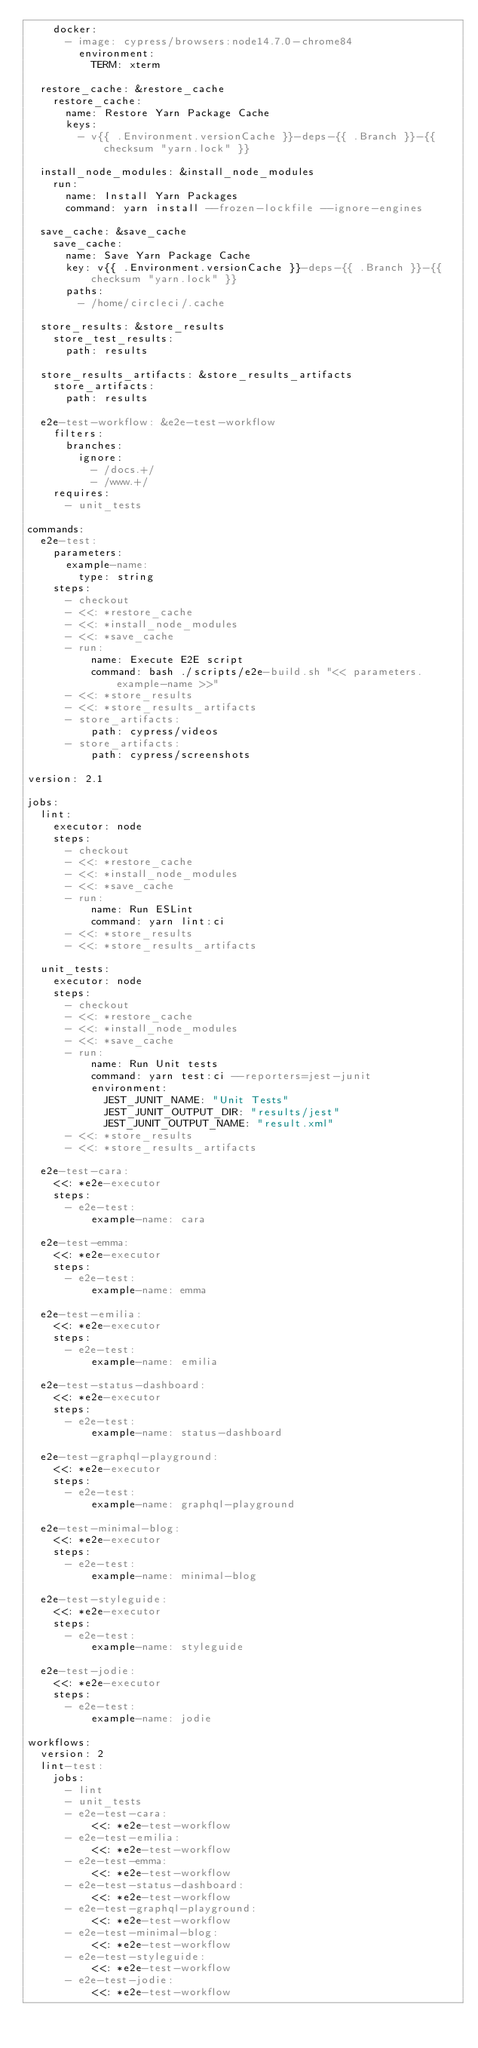<code> <loc_0><loc_0><loc_500><loc_500><_YAML_>    docker:
      - image: cypress/browsers:node14.7.0-chrome84
        environment:
          TERM: xterm

  restore_cache: &restore_cache
    restore_cache:
      name: Restore Yarn Package Cache
      keys:
        - v{{ .Environment.versionCache }}-deps-{{ .Branch }}-{{ checksum "yarn.lock" }}

  install_node_modules: &install_node_modules
    run:
      name: Install Yarn Packages
      command: yarn install --frozen-lockfile --ignore-engines

  save_cache: &save_cache
    save_cache:
      name: Save Yarn Package Cache
      key: v{{ .Environment.versionCache }}-deps-{{ .Branch }}-{{ checksum "yarn.lock" }}
      paths:
        - /home/circleci/.cache

  store_results: &store_results
    store_test_results:
      path: results

  store_results_artifacts: &store_results_artifacts
    store_artifacts:
      path: results

  e2e-test-workflow: &e2e-test-workflow
    filters:
      branches:
        ignore:
          - /docs.+/
          - /www.+/
    requires:
      - unit_tests

commands:
  e2e-test:
    parameters:
      example-name:
        type: string
    steps:
      - checkout
      - <<: *restore_cache
      - <<: *install_node_modules
      - <<: *save_cache
      - run:
          name: Execute E2E script
          command: bash ./scripts/e2e-build.sh "<< parameters.example-name >>"
      - <<: *store_results
      - <<: *store_results_artifacts
      - store_artifacts:
          path: cypress/videos
      - store_artifacts:
          path: cypress/screenshots

version: 2.1

jobs:
  lint:
    executor: node
    steps:
      - checkout
      - <<: *restore_cache
      - <<: *install_node_modules
      - <<: *save_cache
      - run:
          name: Run ESLint
          command: yarn lint:ci
      - <<: *store_results
      - <<: *store_results_artifacts

  unit_tests:
    executor: node
    steps:
      - checkout
      - <<: *restore_cache
      - <<: *install_node_modules
      - <<: *save_cache
      - run:
          name: Run Unit tests
          command: yarn test:ci --reporters=jest-junit
          environment:
            JEST_JUNIT_NAME: "Unit Tests"
            JEST_JUNIT_OUTPUT_DIR: "results/jest"
            JEST_JUNIT_OUTPUT_NAME: "result.xml"
      - <<: *store_results
      - <<: *store_results_artifacts

  e2e-test-cara:
    <<: *e2e-executor
    steps:
      - e2e-test:
          example-name: cara

  e2e-test-emma:
    <<: *e2e-executor
    steps:
      - e2e-test:
          example-name: emma

  e2e-test-emilia:
    <<: *e2e-executor
    steps:
      - e2e-test:
          example-name: emilia

  e2e-test-status-dashboard:
    <<: *e2e-executor
    steps:
      - e2e-test:
          example-name: status-dashboard

  e2e-test-graphql-playground:
    <<: *e2e-executor
    steps:
      - e2e-test:
          example-name: graphql-playground

  e2e-test-minimal-blog:
    <<: *e2e-executor
    steps:
      - e2e-test:
          example-name: minimal-blog

  e2e-test-styleguide:
    <<: *e2e-executor
    steps:
      - e2e-test:
          example-name: styleguide

  e2e-test-jodie:
    <<: *e2e-executor
    steps:
      - e2e-test:
          example-name: jodie

workflows:
  version: 2
  lint-test:
    jobs:
      - lint
      - unit_tests
      - e2e-test-cara:
          <<: *e2e-test-workflow
      - e2e-test-emilia:
          <<: *e2e-test-workflow
      - e2e-test-emma:
          <<: *e2e-test-workflow
      - e2e-test-status-dashboard:
          <<: *e2e-test-workflow
      - e2e-test-graphql-playground:
          <<: *e2e-test-workflow
      - e2e-test-minimal-blog:
          <<: *e2e-test-workflow
      - e2e-test-styleguide:
          <<: *e2e-test-workflow
      - e2e-test-jodie:
          <<: *e2e-test-workflow
</code> 